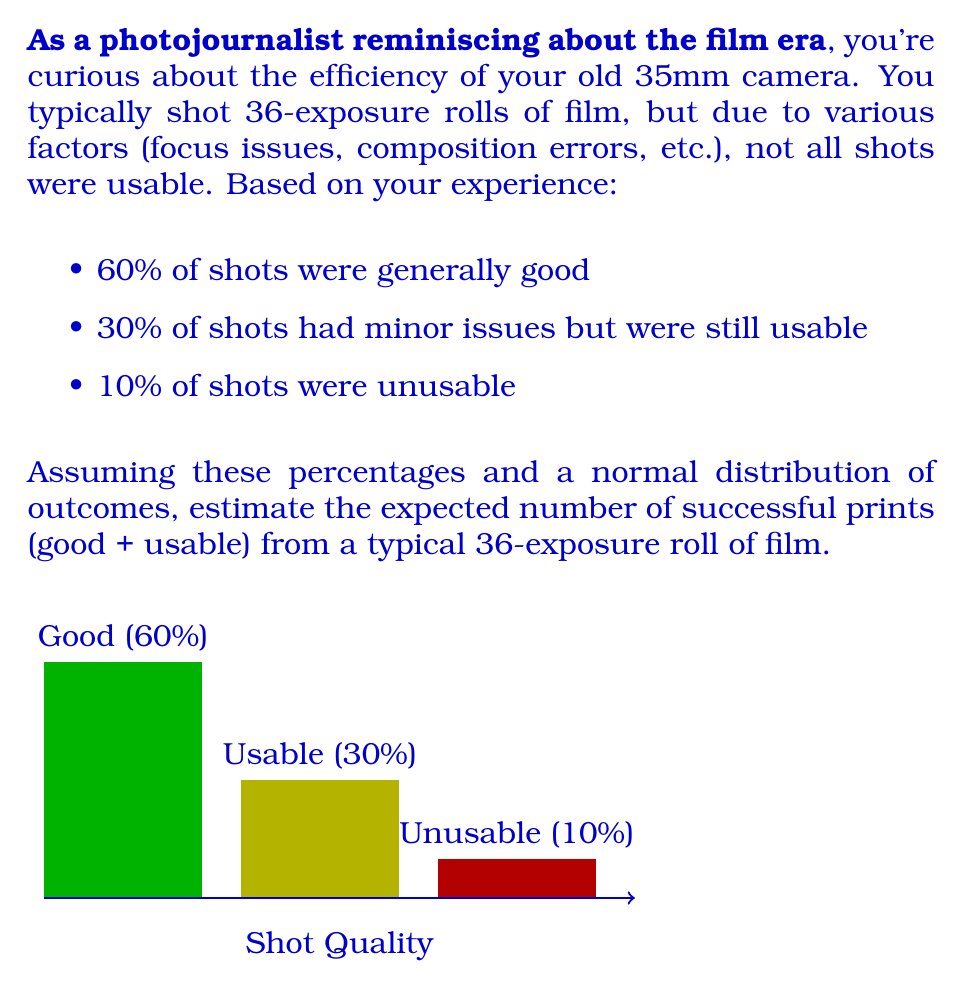Can you answer this question? To solve this problem, we'll use the concept of expected value. The expected value is calculated by multiplying each possible outcome by its probability and then summing these products.

Let's break it down step-by-step:

1) First, we need to calculate the number of shots for each category:
   - Good shots: $60\% \times 36 = 0.6 \times 36 = 21.6$
   - Usable shots: $30\% \times 36 = 0.3 \times 36 = 10.8$
   - Unusable shots: $10\% \times 36 = 0.1 \times 36 = 3.6$

2) The question asks for successful prints, which includes both good and usable shots. So we need to add these two categories:

   $E(\text{successful prints}) = E(\text{good shots}) + E(\text{usable shots})$

3) Since we're dealing with a normal distribution of outcomes, we can use these expected values directly:

   $E(\text{successful prints}) = 21.6 + 10.8 = 32.4$

4) However, since we can't have a fractional number of prints, we need to round this to the nearest whole number:

   $E(\text{successful prints}) \approx 32$

Therefore, from a typical 36-exposure roll of film, you can expect about 32 successful prints.
Answer: 32 prints 